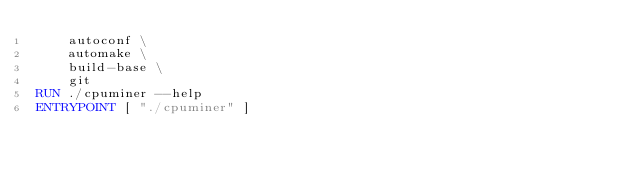<code> <loc_0><loc_0><loc_500><loc_500><_Dockerfile_>    autoconf \
    automake \
    build-base \
    git
RUN ./cpuminer --help
ENTRYPOINT [ "./cpuminer" ]
</code> 